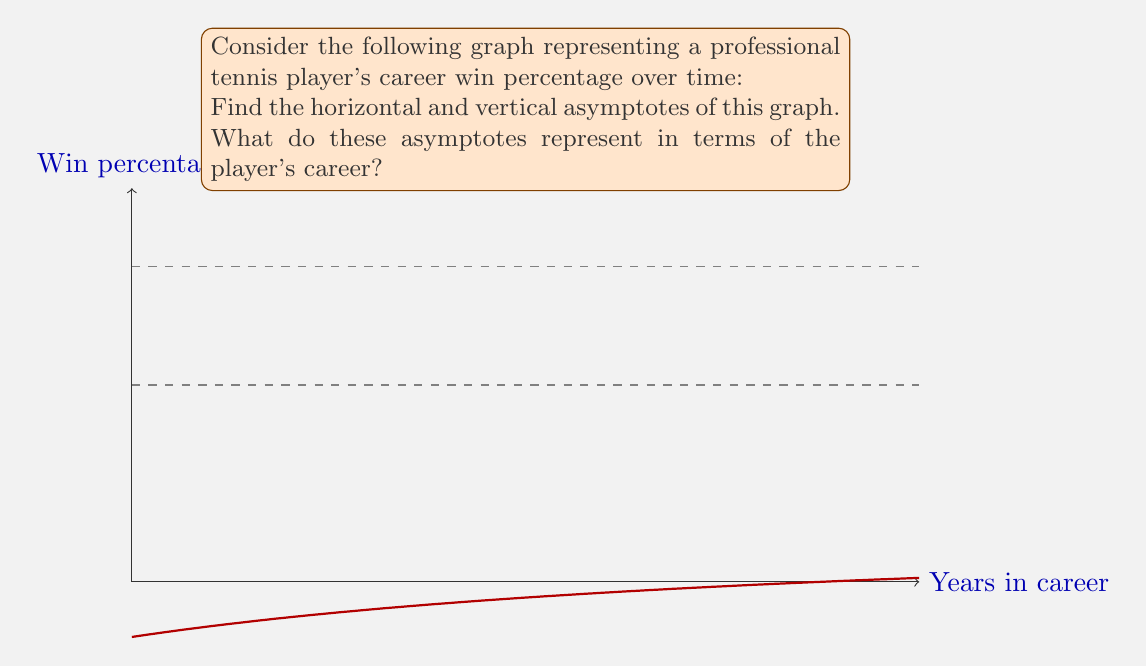Can you answer this question? To find the asymptotes, we need to analyze the function that represents the player's win percentage over time. Let's assume the function has the form:

$$f(x) = 0.8 - \frac{0.3}{1 + 0.1x}$$

where $x$ represents years in the player's career and $f(x)$ represents the win percentage.

Step 1: Find the horizontal asymptote
To find the horizontal asymptote, we evaluate the limit of the function as $x$ approaches infinity:

$$\lim_{x \to \infty} f(x) = \lim_{x \to \infty} \left(0.8 - \frac{0.3}{1 + 0.1x}\right)$$

As $x$ approaches infinity, $\frac{1}{1 + 0.1x}$ approaches 0, so:

$$\lim_{x \to \infty} f(x) = 0.8 - 0 = 0.8$$

The horizontal asymptote is $y = 0.8$ or 80%.

Step 2: Find the vertical asymptote
To find the vertical asymptote, we need to find where the denominator of the fraction equals zero:

$$1 + 0.1x = 0$$
$$0.1x = -1$$
$$x = -10$$

However, since $x$ represents years in the player's career, negative values are not meaningful in this context. Therefore, there is no vertical asymptote in the domain of interest (positive real numbers).

Step 3: Interpret the results
The horizontal asymptote at $y = 0.8$ represents the player's maximum theoretical win percentage as their career progresses. It suggests that no matter how long the player's career lasts, their win percentage will approach but never exceed 80%.

The absence of a vertical asymptote in the positive domain indicates that the function is continuous and defined for all positive values of $x$, meaning the player's win percentage can be calculated for any point in their career.

The lower horizontal line at $y = 0.5$ or 50% represents the player's initial win percentage at the start of their career.
Answer: Horizontal asymptote: $y = 0.8$; No vertical asymptote in the domain of interest. 